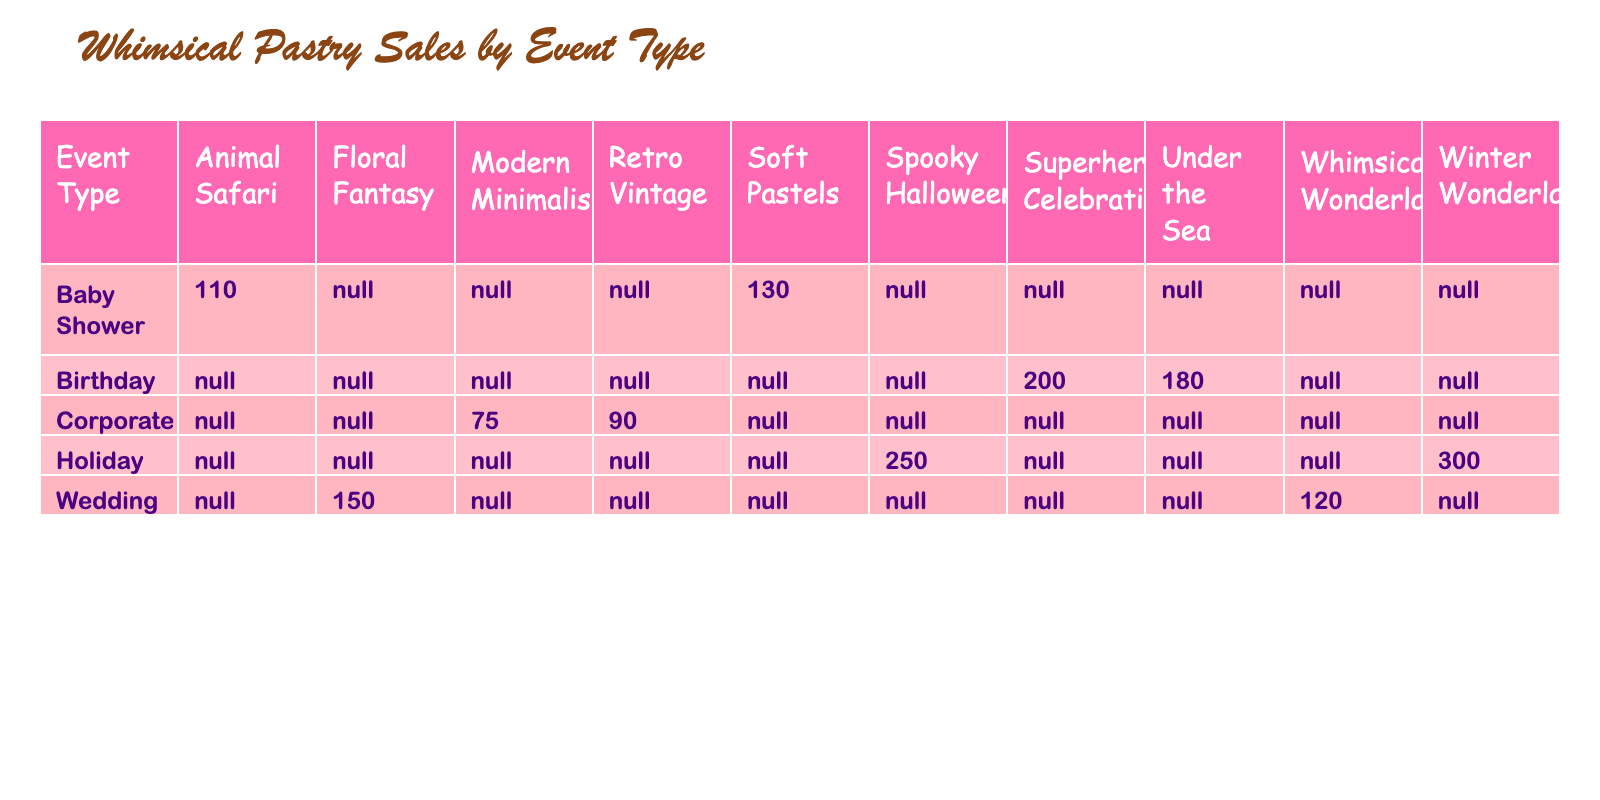What is the total number of units sold for the Wedding event type? To find the total sales for the Wedding event type, we add the units sold for each theme under Wedding: Floral Fantasy (150) + Whimsical Wonderland (120) = 270.
Answer: 270 Which pastry theme had the highest units sold in the Birthday event type? By examining the Birthday event themes, Superhero Celebration sold 200 units and Under the Sea sold 180 units. The highest is Superhero Celebration with 200 units sold.
Answer: Superhero Celebration True or False: The Spooky Halloween theme sold more units than both Baby Shower themes combined. We calculate the total units sold for Baby Shower: Soft Pastels (130) + Animal Safari (110) = 240. Spooky Halloween sold 250 units. Since 250 > 240, the statement is true.
Answer: True What is the average price per unit for the Corporate event type? The prices for Corporate themes are Modern Minimalism ($8.00) and Retro Vintage ($7.50). To find the average price, we add them (8.00 + 7.50 = 15.50) and then divide by 2, which results in an average of 7.75.
Answer: 7.75 Which event type sold the least number of units in total, and how many units were sold? We sum the units sold for each event type: Wedding (270), Birthday (380), Corporate (165), Holiday (550), Baby Shower (240). The Corporate event type had the least at 165 units sold.
Answer: Corporate, 165 